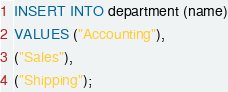<code> <loc_0><loc_0><loc_500><loc_500><_SQL_>
INSERT INTO department (name)
VALUES ("Accounting"),
("Sales"),
("Shipping");</code> 